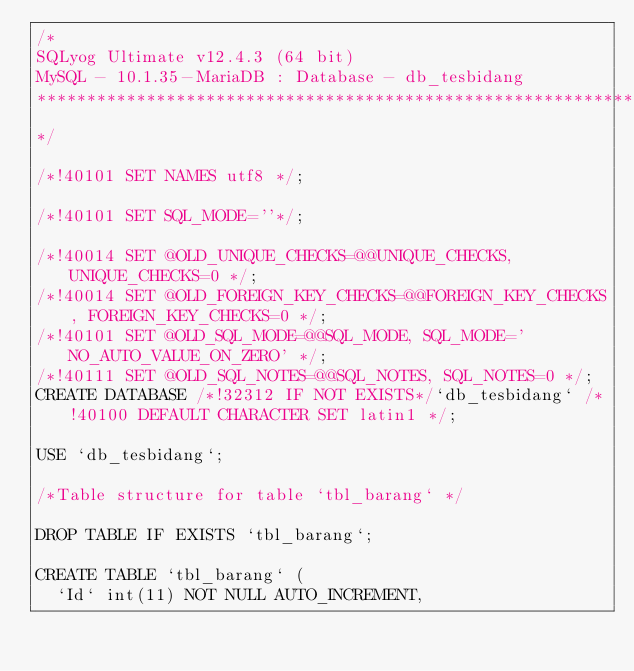<code> <loc_0><loc_0><loc_500><loc_500><_SQL_>/*
SQLyog Ultimate v12.4.3 (64 bit)
MySQL - 10.1.35-MariaDB : Database - db_tesbidang
*********************************************************************
*/

/*!40101 SET NAMES utf8 */;

/*!40101 SET SQL_MODE=''*/;

/*!40014 SET @OLD_UNIQUE_CHECKS=@@UNIQUE_CHECKS, UNIQUE_CHECKS=0 */;
/*!40014 SET @OLD_FOREIGN_KEY_CHECKS=@@FOREIGN_KEY_CHECKS, FOREIGN_KEY_CHECKS=0 */;
/*!40101 SET @OLD_SQL_MODE=@@SQL_MODE, SQL_MODE='NO_AUTO_VALUE_ON_ZERO' */;
/*!40111 SET @OLD_SQL_NOTES=@@SQL_NOTES, SQL_NOTES=0 */;
CREATE DATABASE /*!32312 IF NOT EXISTS*/`db_tesbidang` /*!40100 DEFAULT CHARACTER SET latin1 */;

USE `db_tesbidang`;

/*Table structure for table `tbl_barang` */

DROP TABLE IF EXISTS `tbl_barang`;

CREATE TABLE `tbl_barang` (
  `Id` int(11) NOT NULL AUTO_INCREMENT,</code> 